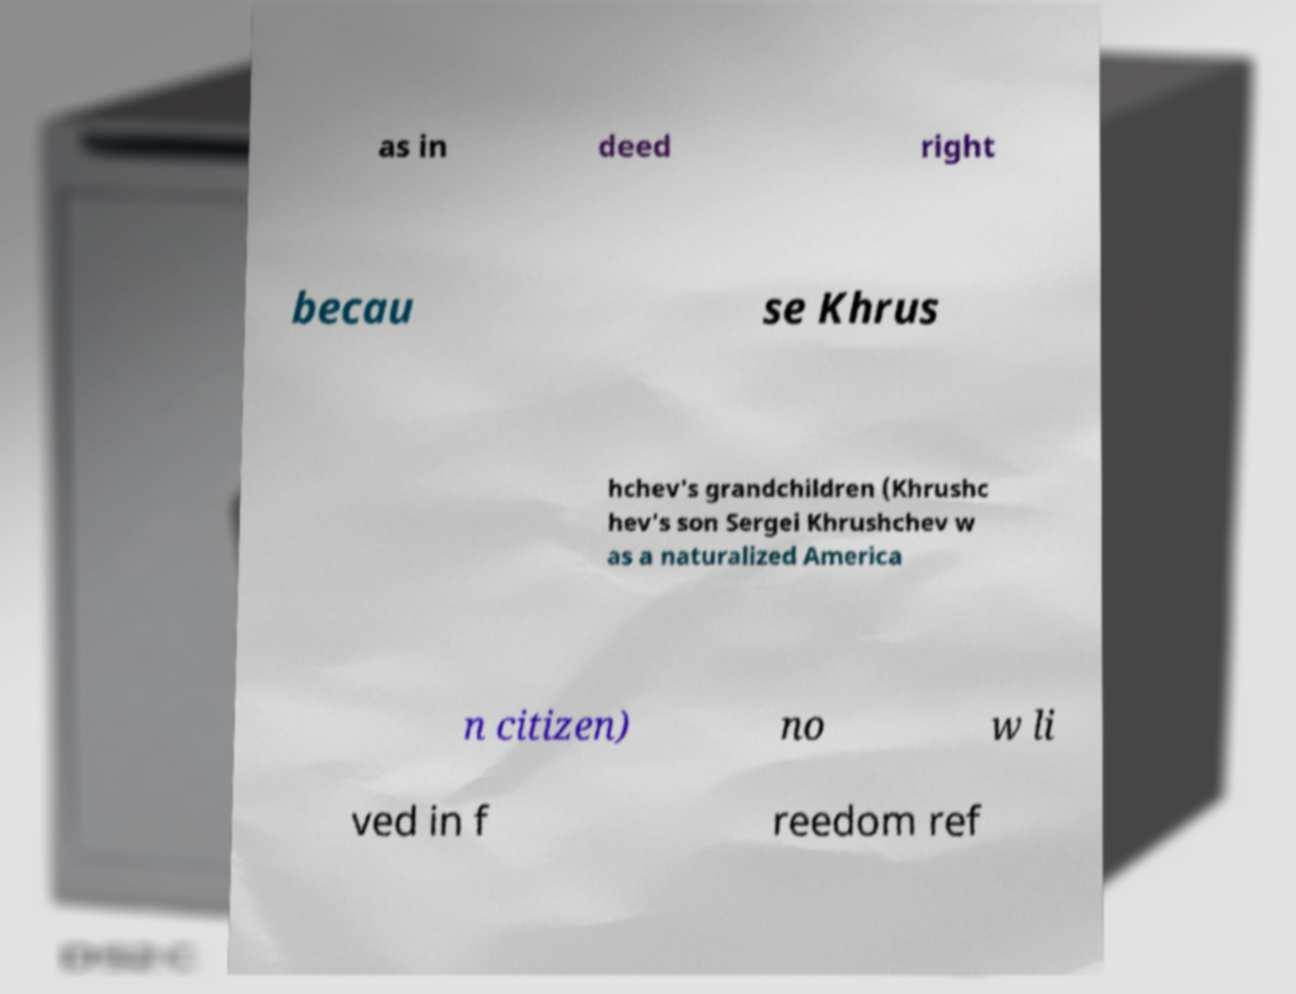Can you read and provide the text displayed in the image?This photo seems to have some interesting text. Can you extract and type it out for me? as in deed right becau se Khrus hchev's grandchildren (Khrushc hev's son Sergei Khrushchev w as a naturalized America n citizen) no w li ved in f reedom ref 